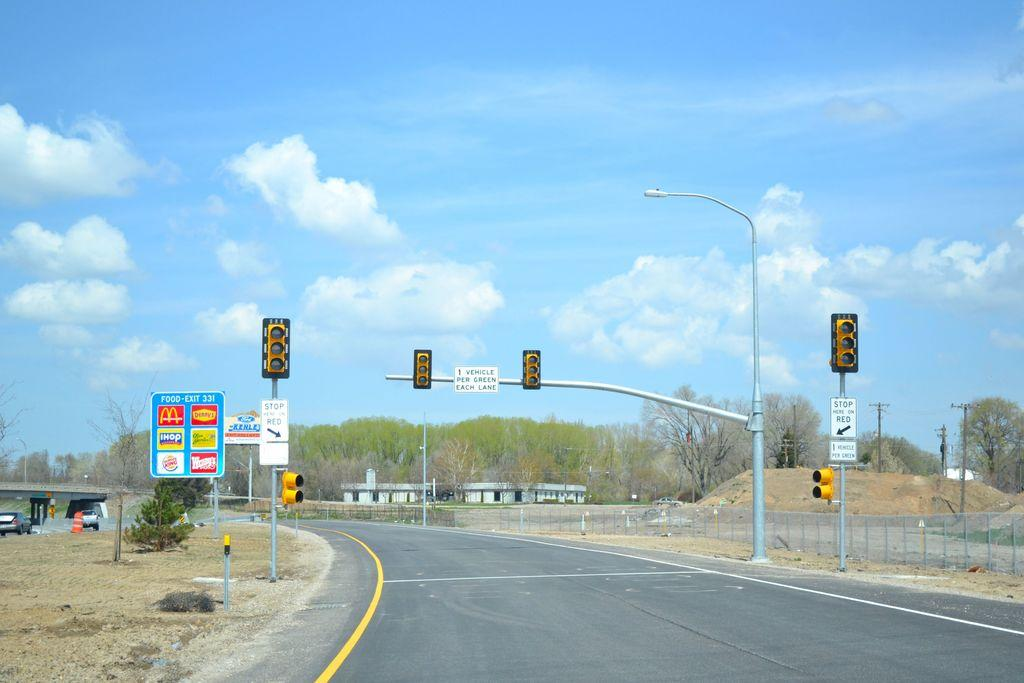<image>
Share a concise interpretation of the image provided. a blue sign with iHop written on it 